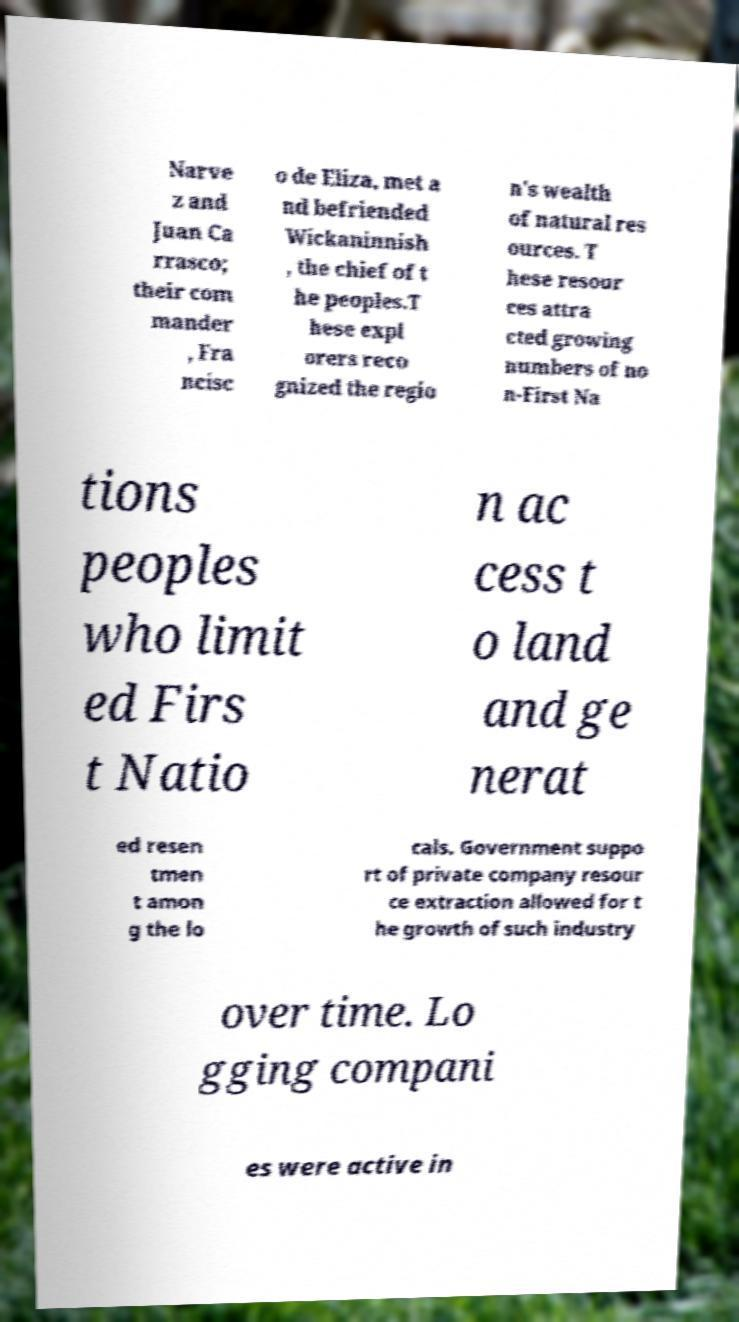Can you read and provide the text displayed in the image?This photo seems to have some interesting text. Can you extract and type it out for me? Narve z and Juan Ca rrasco; their com mander , Fra ncisc o de Eliza, met a nd befriended Wickaninnish , the chief of t he peoples.T hese expl orers reco gnized the regio n's wealth of natural res ources. T hese resour ces attra cted growing numbers of no n-First Na tions peoples who limit ed Firs t Natio n ac cess t o land and ge nerat ed resen tmen t amon g the lo cals. Government suppo rt of private company resour ce extraction allowed for t he growth of such industry over time. Lo gging compani es were active in 